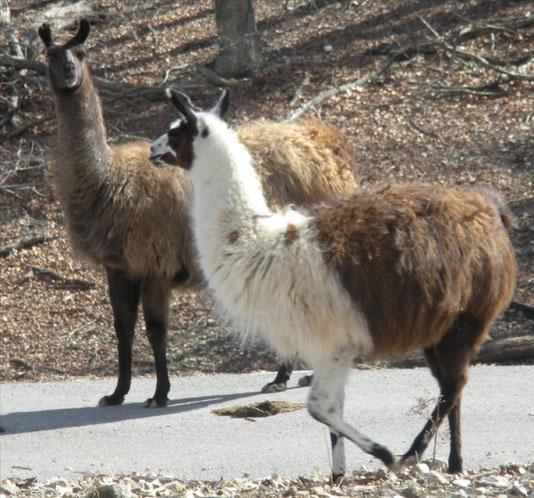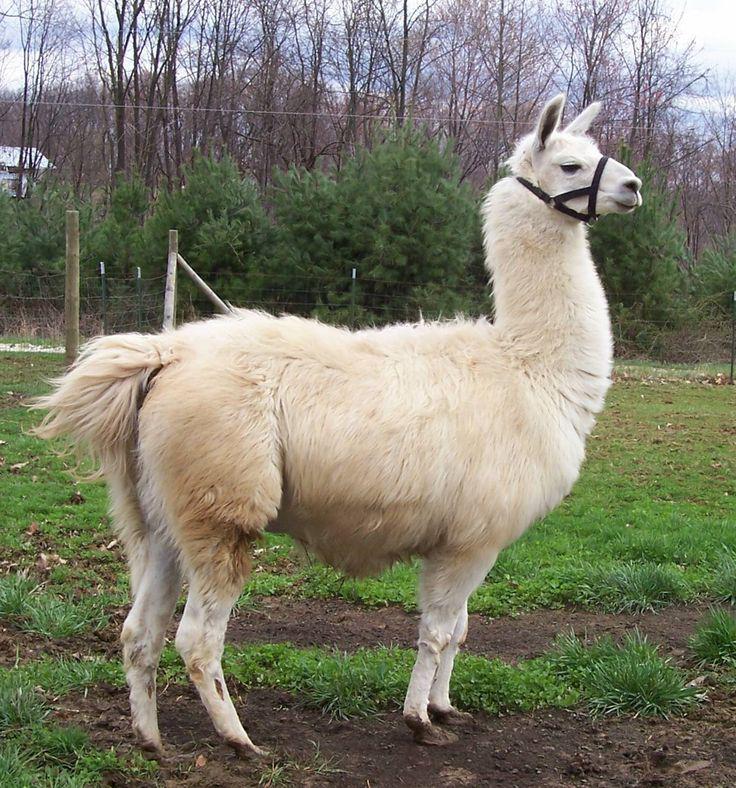The first image is the image on the left, the second image is the image on the right. Assess this claim about the two images: "The right image contains one right-facing llama wearing a head harness, and the left image contains two llamas with bodies turned to the left.". Correct or not? Answer yes or no. Yes. The first image is the image on the left, the second image is the image on the right. For the images shown, is this caption "One llama is looking to the right." true? Answer yes or no. Yes. 